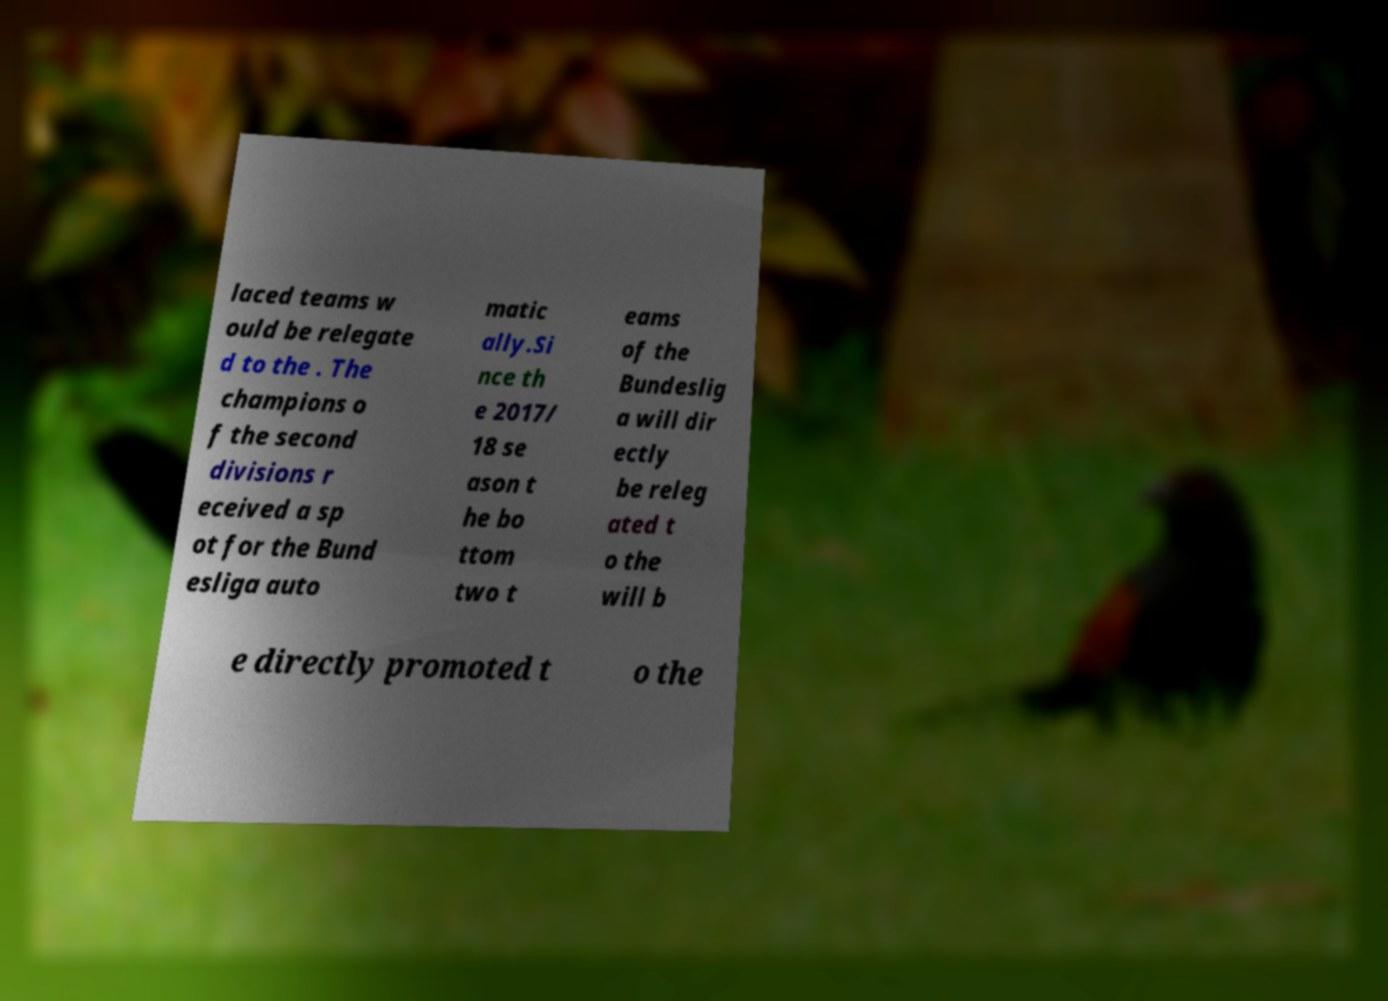What messages or text are displayed in this image? I need them in a readable, typed format. laced teams w ould be relegate d to the . The champions o f the second divisions r eceived a sp ot for the Bund esliga auto matic ally.Si nce th e 2017/ 18 se ason t he bo ttom two t eams of the Bundeslig a will dir ectly be releg ated t o the will b e directly promoted t o the 